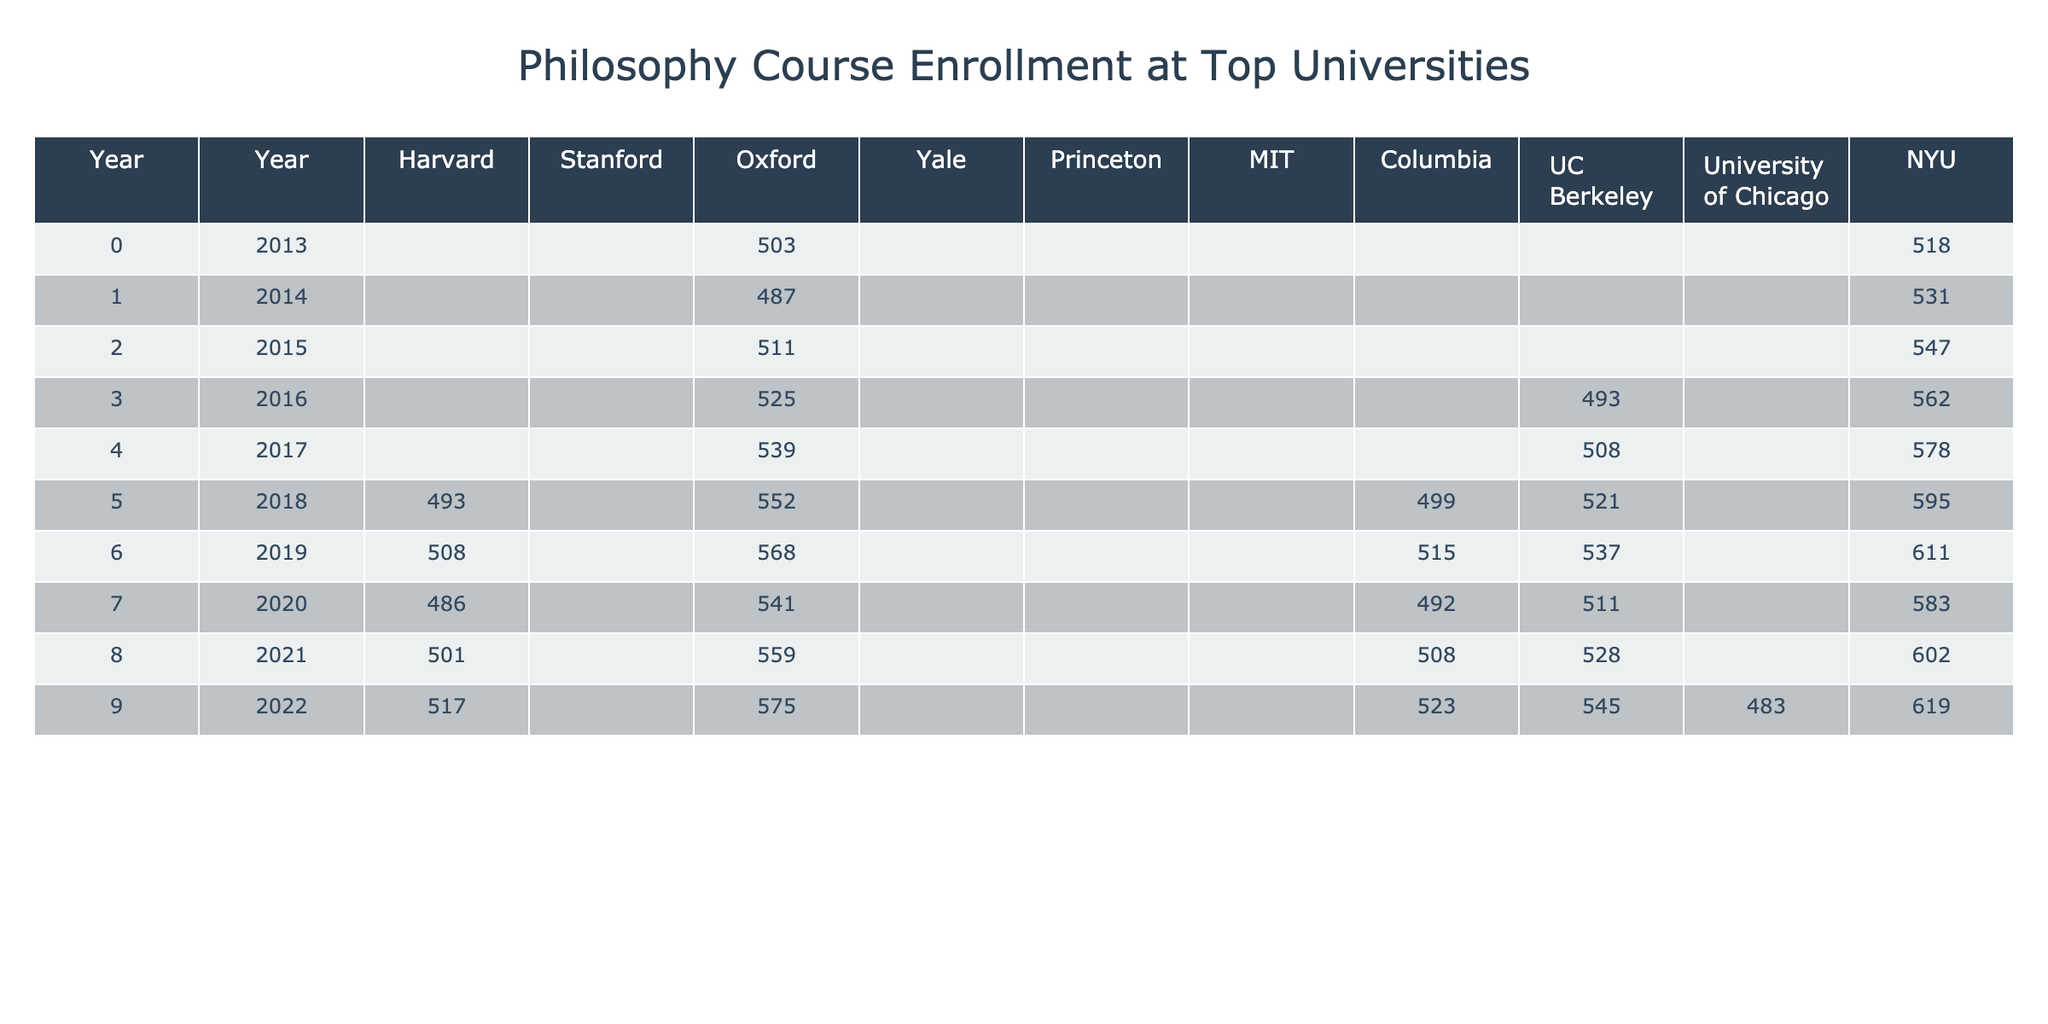What was the highest enrollment in philosophy courses across all universities in 2019? Looking at the data for 2019, the highest enrollment is from NYU with a value of 611.
Answer: 611 Which university had the lowest enrollment in philosophy courses in 2015? In 2015, the university with the lowest enrollment is MIT, which had 185 students enrolled.
Answer: 185 What was the overall trend in enrollment from 2013 to 2022? By comparing the values from each year, it's observed that enrollment generally increased over the years, especially notable in universities like NYU and Oxford.
Answer: Increasing Did the enrollment at UC Berkeley exceed the median enrollment in 2020? The median enrollment for all universities in 2020 is found to be around 486. UC Berkeley's enrollment in 2020 was 511, which exceeds the median.
Answer: Yes What was the average enrollment at Princeton from 2013 to 2022? The total enrollment over the years at Princeton is (301 + 315 + 328 + 359 + 375 + 391 + 372 + 388 + 405) = 4020. Dividing by the number of years (9), the average enrollment is 4020 / 9 = 446.67.
Answer: 446.67 How much did enrollment at Yale decrease from 2019 to 2020? In 2019, Yale had 459 enrollments, which dropped to 437 in 2020. The decrease is calculated as 459 - 437 = 22.
Answer: 22 Which university had a consistent enrollment growth from 2013 to 2022? By reviewing the enrollment data for universities like Harvard and Stanford, it's clear both had an upward trend each year, indicating consistent growth.
Answer: Harvard and Stanford What is the difference in enrollment between the highest and lowest numbers at Oxford from 2013 to 2022? The highest enrollment at Oxford during this period is 575 in 2022, and the lowest was 503 in 2013. The difference is 575 - 503 = 72.
Answer: 72 In which year did MIT have the largest enrollment in philosophy courses? Checking the enrollment numbers, MIT had its largest enrollment in 2022 with 274 students.
Answer: 2022 Was the enrollment at Columbia ever below the median enrollment for all universities in any year? Evaluating the data year by year, Columbia's enrollment in 2014 (438) and 2015 (451) was below the median for those respective years.
Answer: Yes What is the total enrollment for all universities in 2016? Summing the enrollments for 2016 gives 461 + 335 + 525 + 412 + 342 + 201 + 467 + 493 + 431 + 562 = 3,744.
Answer: 3744 